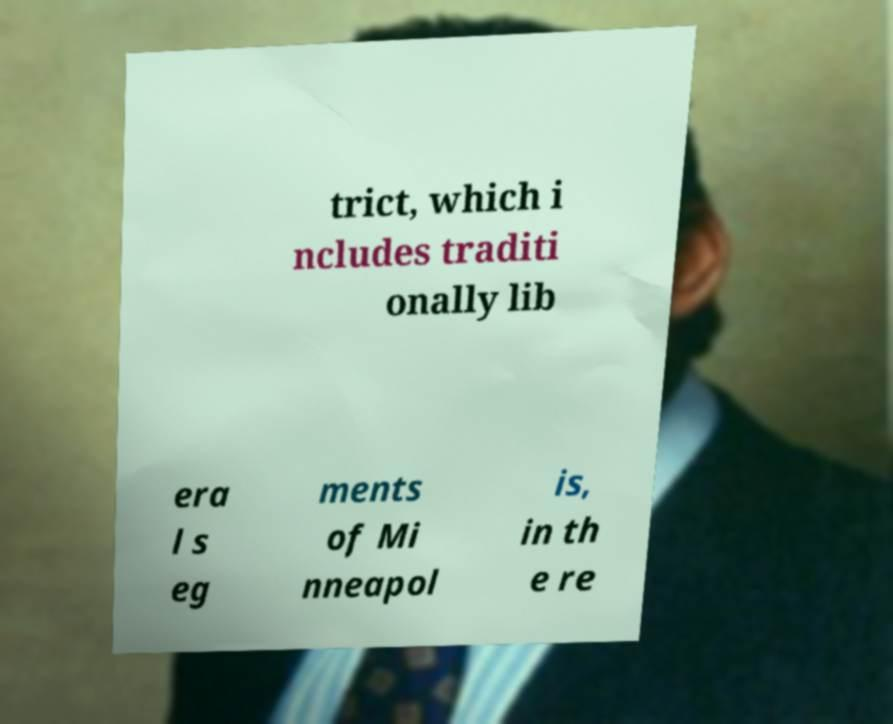For documentation purposes, I need the text within this image transcribed. Could you provide that? trict, which i ncludes traditi onally lib era l s eg ments of Mi nneapol is, in th e re 